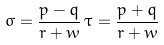Convert formula to latex. <formula><loc_0><loc_0><loc_500><loc_500>\sigma = \frac { p - q } { r + w } \, \tau = \frac { p + q } { r + w }</formula> 